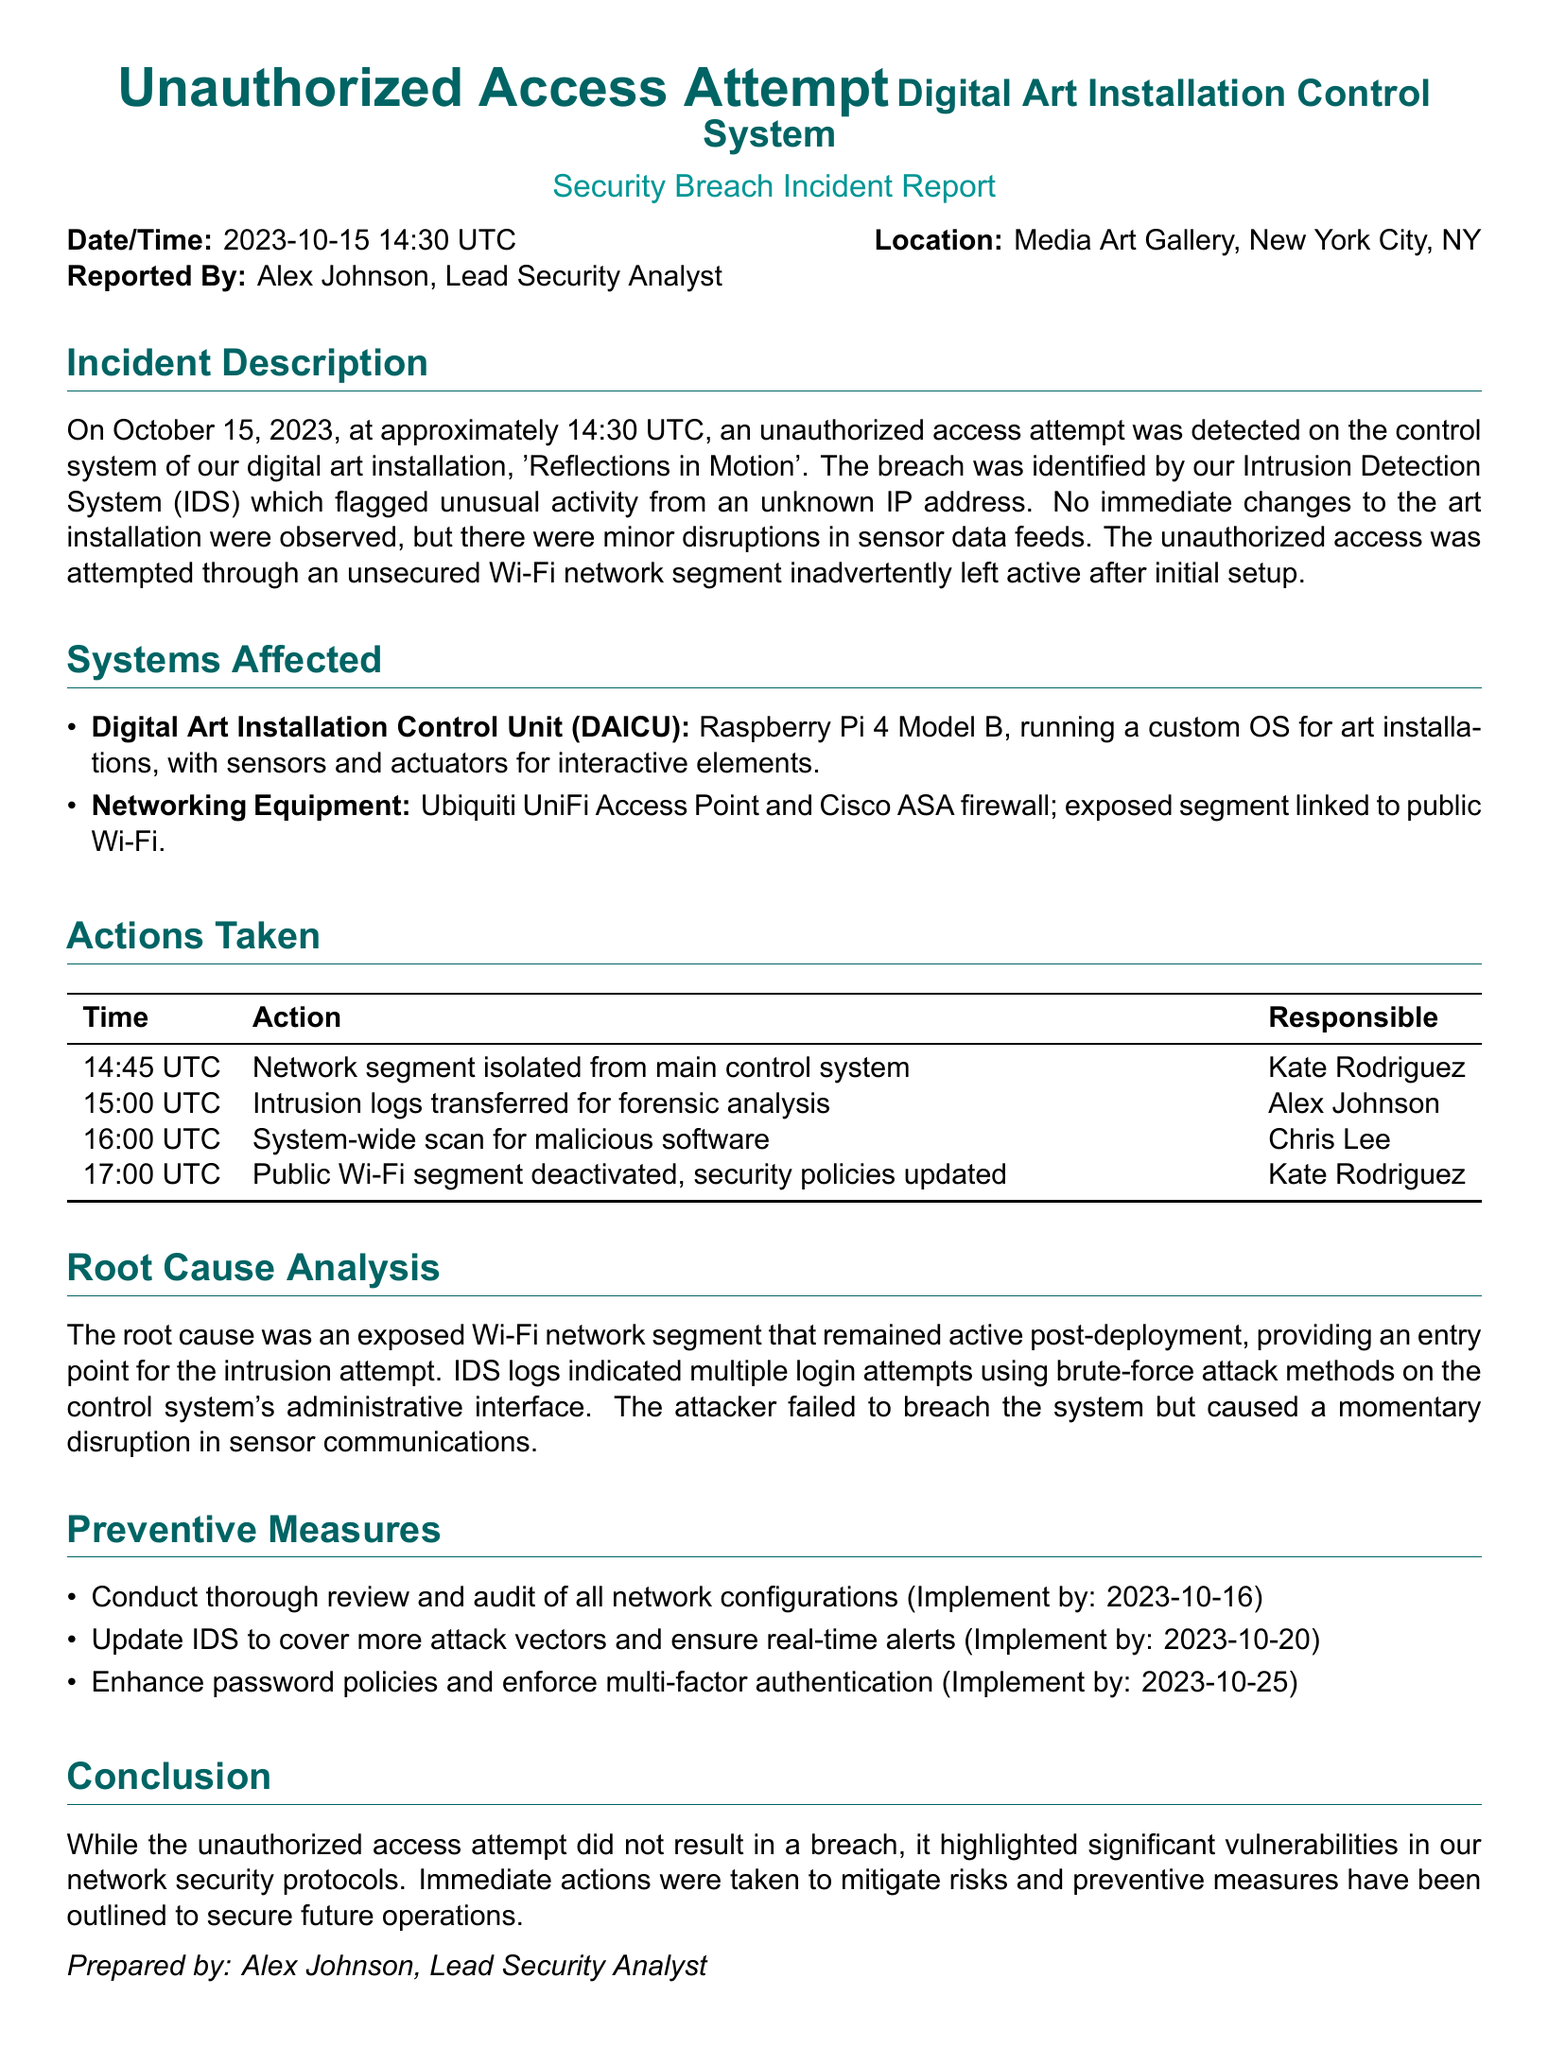what was the date of the incident? The date of the incident is stated in the report as October 15, 2023.
Answer: October 15, 2023 who reported the incident? The report identifies the person who reported the incident as Alex Johnson, Lead Security Analyst.
Answer: Alex Johnson what system was attempted to be accessed? The unauthorized access attempt was made on the control system of the digital art installation named 'Reflections in Motion'.
Answer: 'Reflections in Motion' how many login attempts were indicated by the IDS logs? The document mentions multiple login attempts but does not specify the exact number.
Answer: multiple what was the time when the public Wi-Fi segment was deactivated? The report lists the time when the public Wi-Fi segment was deactivated as 17:00 UTC.
Answer: 17:00 UTC what equipment was listed under networking equipment? The networking equipment mentioned in the report includes a Ubiquiti UniFi Access Point and Cisco ASA firewall.
Answer: Ubiquiti UniFi Access Point and Cisco ASA firewall what is the root cause of the incident? The root cause identified in the report is an exposed Wi-Fi network segment that was left active post-deployment.
Answer: exposed Wi-Fi network segment which measure is planned to be implemented by October 25, 2023? The report states that the enhancement of password policies and enforcement of multi-factor authentication is planned for this date.
Answer: enhance password policies and enforce multi-factor authentication 